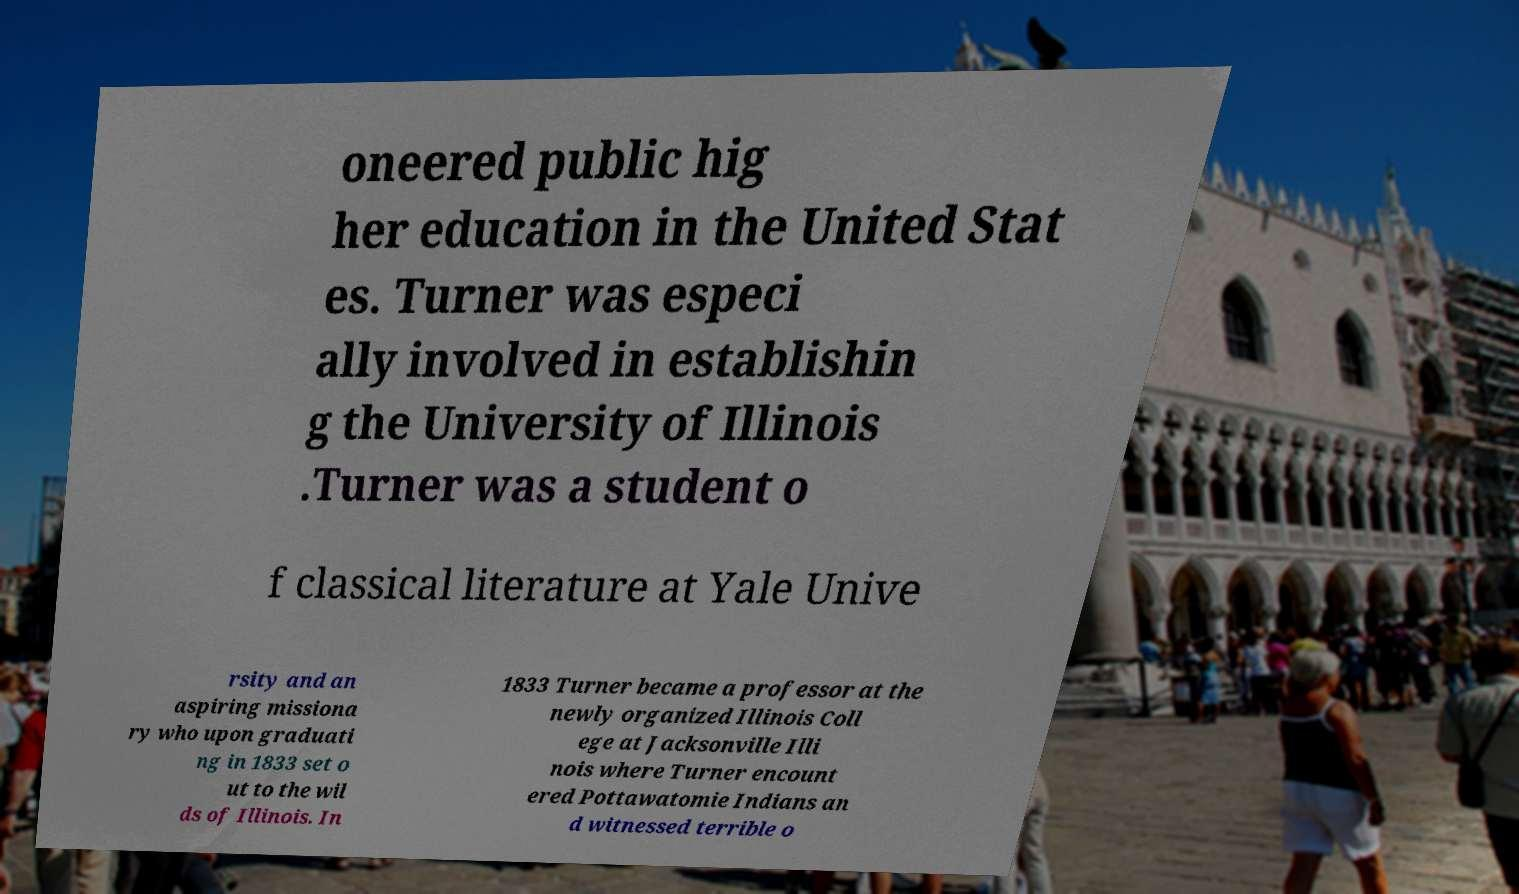Can you accurately transcribe the text from the provided image for me? oneered public hig her education in the United Stat es. Turner was especi ally involved in establishin g the University of Illinois .Turner was a student o f classical literature at Yale Unive rsity and an aspiring missiona ry who upon graduati ng in 1833 set o ut to the wil ds of Illinois. In 1833 Turner became a professor at the newly organized Illinois Coll ege at Jacksonville Illi nois where Turner encount ered Pottawatomie Indians an d witnessed terrible o 